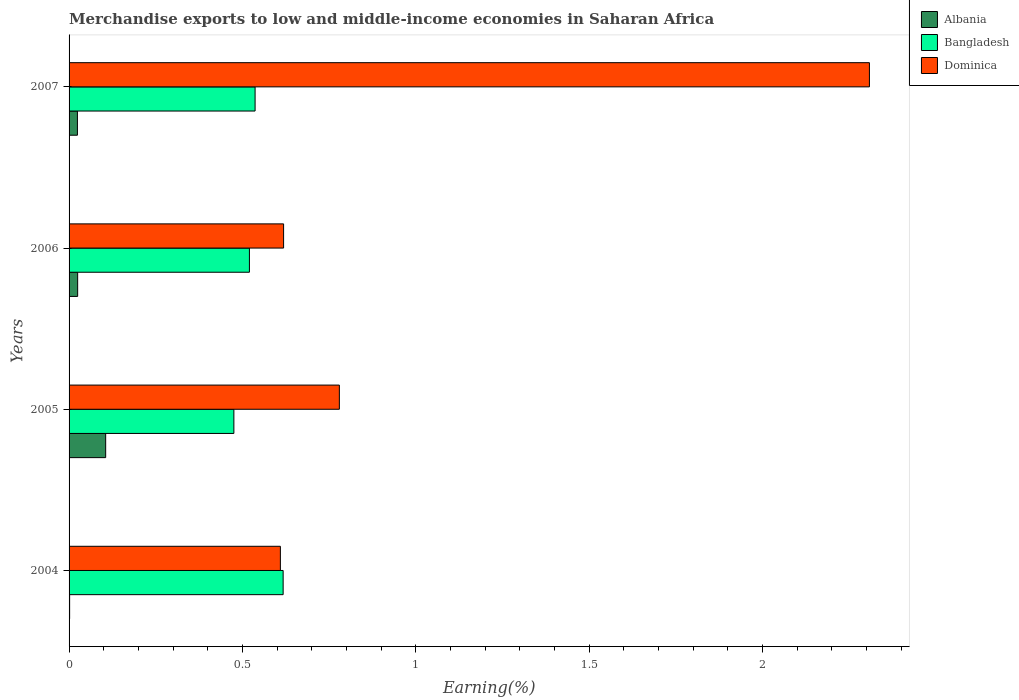Are the number of bars per tick equal to the number of legend labels?
Provide a short and direct response. Yes. Are the number of bars on each tick of the Y-axis equal?
Provide a succinct answer. Yes. How many bars are there on the 2nd tick from the top?
Your response must be concise. 3. What is the label of the 1st group of bars from the top?
Give a very brief answer. 2007. In how many cases, is the number of bars for a given year not equal to the number of legend labels?
Give a very brief answer. 0. What is the percentage of amount earned from merchandise exports in Albania in 2006?
Keep it short and to the point. 0.02. Across all years, what is the maximum percentage of amount earned from merchandise exports in Dominica?
Provide a succinct answer. 2.31. Across all years, what is the minimum percentage of amount earned from merchandise exports in Bangladesh?
Give a very brief answer. 0.48. In which year was the percentage of amount earned from merchandise exports in Dominica maximum?
Your response must be concise. 2007. What is the total percentage of amount earned from merchandise exports in Albania in the graph?
Provide a short and direct response. 0.16. What is the difference between the percentage of amount earned from merchandise exports in Bangladesh in 2005 and that in 2006?
Make the answer very short. -0.04. What is the difference between the percentage of amount earned from merchandise exports in Dominica in 2004 and the percentage of amount earned from merchandise exports in Albania in 2007?
Make the answer very short. 0.59. What is the average percentage of amount earned from merchandise exports in Bangladesh per year?
Keep it short and to the point. 0.54. In the year 2005, what is the difference between the percentage of amount earned from merchandise exports in Dominica and percentage of amount earned from merchandise exports in Albania?
Keep it short and to the point. 0.67. What is the ratio of the percentage of amount earned from merchandise exports in Bangladesh in 2006 to that in 2007?
Ensure brevity in your answer.  0.97. Is the percentage of amount earned from merchandise exports in Bangladesh in 2006 less than that in 2007?
Make the answer very short. Yes. Is the difference between the percentage of amount earned from merchandise exports in Dominica in 2004 and 2006 greater than the difference between the percentage of amount earned from merchandise exports in Albania in 2004 and 2006?
Your response must be concise. Yes. What is the difference between the highest and the second highest percentage of amount earned from merchandise exports in Dominica?
Your answer should be compact. 1.53. What is the difference between the highest and the lowest percentage of amount earned from merchandise exports in Dominica?
Provide a short and direct response. 1.7. Is the sum of the percentage of amount earned from merchandise exports in Albania in 2004 and 2006 greater than the maximum percentage of amount earned from merchandise exports in Dominica across all years?
Provide a succinct answer. No. What does the 3rd bar from the top in 2004 represents?
Provide a succinct answer. Albania. What does the 1st bar from the bottom in 2007 represents?
Offer a terse response. Albania. Is it the case that in every year, the sum of the percentage of amount earned from merchandise exports in Dominica and percentage of amount earned from merchandise exports in Albania is greater than the percentage of amount earned from merchandise exports in Bangladesh?
Your response must be concise. No. How many bars are there?
Provide a succinct answer. 12. Are all the bars in the graph horizontal?
Provide a succinct answer. Yes. How many years are there in the graph?
Keep it short and to the point. 4. Does the graph contain any zero values?
Ensure brevity in your answer.  No. Where does the legend appear in the graph?
Ensure brevity in your answer.  Top right. How many legend labels are there?
Keep it short and to the point. 3. How are the legend labels stacked?
Make the answer very short. Vertical. What is the title of the graph?
Provide a short and direct response. Merchandise exports to low and middle-income economies in Saharan Africa. Does "Gambia, The" appear as one of the legend labels in the graph?
Provide a short and direct response. No. What is the label or title of the X-axis?
Your answer should be compact. Earning(%). What is the label or title of the Y-axis?
Make the answer very short. Years. What is the Earning(%) in Albania in 2004?
Your response must be concise. 0. What is the Earning(%) of Bangladesh in 2004?
Offer a very short reply. 0.62. What is the Earning(%) in Dominica in 2004?
Make the answer very short. 0.61. What is the Earning(%) of Albania in 2005?
Provide a succinct answer. 0.11. What is the Earning(%) of Bangladesh in 2005?
Offer a very short reply. 0.48. What is the Earning(%) in Dominica in 2005?
Offer a very short reply. 0.78. What is the Earning(%) in Albania in 2006?
Give a very brief answer. 0.02. What is the Earning(%) in Bangladesh in 2006?
Keep it short and to the point. 0.52. What is the Earning(%) in Dominica in 2006?
Offer a terse response. 0.62. What is the Earning(%) in Albania in 2007?
Give a very brief answer. 0.02. What is the Earning(%) of Bangladesh in 2007?
Provide a succinct answer. 0.54. What is the Earning(%) of Dominica in 2007?
Offer a very short reply. 2.31. Across all years, what is the maximum Earning(%) in Albania?
Give a very brief answer. 0.11. Across all years, what is the maximum Earning(%) in Bangladesh?
Ensure brevity in your answer.  0.62. Across all years, what is the maximum Earning(%) in Dominica?
Your response must be concise. 2.31. Across all years, what is the minimum Earning(%) in Albania?
Offer a very short reply. 0. Across all years, what is the minimum Earning(%) in Bangladesh?
Make the answer very short. 0.48. Across all years, what is the minimum Earning(%) in Dominica?
Your response must be concise. 0.61. What is the total Earning(%) in Albania in the graph?
Your response must be concise. 0.16. What is the total Earning(%) in Bangladesh in the graph?
Ensure brevity in your answer.  2.15. What is the total Earning(%) in Dominica in the graph?
Your response must be concise. 4.32. What is the difference between the Earning(%) in Albania in 2004 and that in 2005?
Ensure brevity in your answer.  -0.1. What is the difference between the Earning(%) of Bangladesh in 2004 and that in 2005?
Offer a very short reply. 0.14. What is the difference between the Earning(%) of Dominica in 2004 and that in 2005?
Your answer should be compact. -0.17. What is the difference between the Earning(%) of Albania in 2004 and that in 2006?
Provide a succinct answer. -0.02. What is the difference between the Earning(%) of Bangladesh in 2004 and that in 2006?
Your response must be concise. 0.1. What is the difference between the Earning(%) in Dominica in 2004 and that in 2006?
Keep it short and to the point. -0.01. What is the difference between the Earning(%) of Albania in 2004 and that in 2007?
Your answer should be very brief. -0.02. What is the difference between the Earning(%) in Bangladesh in 2004 and that in 2007?
Keep it short and to the point. 0.08. What is the difference between the Earning(%) of Dominica in 2004 and that in 2007?
Provide a succinct answer. -1.7. What is the difference between the Earning(%) of Albania in 2005 and that in 2006?
Keep it short and to the point. 0.08. What is the difference between the Earning(%) of Bangladesh in 2005 and that in 2006?
Your answer should be compact. -0.04. What is the difference between the Earning(%) in Dominica in 2005 and that in 2006?
Offer a very short reply. 0.16. What is the difference between the Earning(%) of Albania in 2005 and that in 2007?
Your response must be concise. 0.08. What is the difference between the Earning(%) in Bangladesh in 2005 and that in 2007?
Provide a succinct answer. -0.06. What is the difference between the Earning(%) of Dominica in 2005 and that in 2007?
Keep it short and to the point. -1.53. What is the difference between the Earning(%) of Albania in 2006 and that in 2007?
Make the answer very short. 0. What is the difference between the Earning(%) of Bangladesh in 2006 and that in 2007?
Your answer should be very brief. -0.02. What is the difference between the Earning(%) in Dominica in 2006 and that in 2007?
Make the answer very short. -1.69. What is the difference between the Earning(%) in Albania in 2004 and the Earning(%) in Bangladesh in 2005?
Offer a terse response. -0.47. What is the difference between the Earning(%) in Albania in 2004 and the Earning(%) in Dominica in 2005?
Offer a very short reply. -0.78. What is the difference between the Earning(%) in Bangladesh in 2004 and the Earning(%) in Dominica in 2005?
Ensure brevity in your answer.  -0.16. What is the difference between the Earning(%) in Albania in 2004 and the Earning(%) in Bangladesh in 2006?
Provide a succinct answer. -0.52. What is the difference between the Earning(%) in Albania in 2004 and the Earning(%) in Dominica in 2006?
Offer a terse response. -0.62. What is the difference between the Earning(%) of Bangladesh in 2004 and the Earning(%) of Dominica in 2006?
Your response must be concise. -0. What is the difference between the Earning(%) of Albania in 2004 and the Earning(%) of Bangladesh in 2007?
Offer a terse response. -0.54. What is the difference between the Earning(%) of Albania in 2004 and the Earning(%) of Dominica in 2007?
Offer a very short reply. -2.31. What is the difference between the Earning(%) in Bangladesh in 2004 and the Earning(%) in Dominica in 2007?
Your response must be concise. -1.69. What is the difference between the Earning(%) in Albania in 2005 and the Earning(%) in Bangladesh in 2006?
Provide a succinct answer. -0.41. What is the difference between the Earning(%) in Albania in 2005 and the Earning(%) in Dominica in 2006?
Your answer should be compact. -0.51. What is the difference between the Earning(%) in Bangladesh in 2005 and the Earning(%) in Dominica in 2006?
Your answer should be compact. -0.14. What is the difference between the Earning(%) of Albania in 2005 and the Earning(%) of Bangladesh in 2007?
Your response must be concise. -0.43. What is the difference between the Earning(%) in Albania in 2005 and the Earning(%) in Dominica in 2007?
Ensure brevity in your answer.  -2.2. What is the difference between the Earning(%) of Bangladesh in 2005 and the Earning(%) of Dominica in 2007?
Provide a short and direct response. -1.83. What is the difference between the Earning(%) of Albania in 2006 and the Earning(%) of Bangladesh in 2007?
Your response must be concise. -0.51. What is the difference between the Earning(%) in Albania in 2006 and the Earning(%) in Dominica in 2007?
Give a very brief answer. -2.28. What is the difference between the Earning(%) of Bangladesh in 2006 and the Earning(%) of Dominica in 2007?
Offer a very short reply. -1.79. What is the average Earning(%) in Albania per year?
Offer a terse response. 0.04. What is the average Earning(%) of Bangladesh per year?
Make the answer very short. 0.54. What is the average Earning(%) in Dominica per year?
Make the answer very short. 1.08. In the year 2004, what is the difference between the Earning(%) in Albania and Earning(%) in Bangladesh?
Your answer should be compact. -0.62. In the year 2004, what is the difference between the Earning(%) in Albania and Earning(%) in Dominica?
Make the answer very short. -0.61. In the year 2004, what is the difference between the Earning(%) in Bangladesh and Earning(%) in Dominica?
Provide a succinct answer. 0.01. In the year 2005, what is the difference between the Earning(%) of Albania and Earning(%) of Bangladesh?
Your answer should be very brief. -0.37. In the year 2005, what is the difference between the Earning(%) in Albania and Earning(%) in Dominica?
Offer a very short reply. -0.67. In the year 2005, what is the difference between the Earning(%) of Bangladesh and Earning(%) of Dominica?
Keep it short and to the point. -0.3. In the year 2006, what is the difference between the Earning(%) in Albania and Earning(%) in Bangladesh?
Your response must be concise. -0.5. In the year 2006, what is the difference between the Earning(%) of Albania and Earning(%) of Dominica?
Your answer should be very brief. -0.59. In the year 2006, what is the difference between the Earning(%) of Bangladesh and Earning(%) of Dominica?
Provide a succinct answer. -0.1. In the year 2007, what is the difference between the Earning(%) in Albania and Earning(%) in Bangladesh?
Your answer should be compact. -0.51. In the year 2007, what is the difference between the Earning(%) of Albania and Earning(%) of Dominica?
Your answer should be very brief. -2.28. In the year 2007, what is the difference between the Earning(%) in Bangladesh and Earning(%) in Dominica?
Offer a terse response. -1.77. What is the ratio of the Earning(%) of Albania in 2004 to that in 2005?
Your answer should be very brief. 0.02. What is the ratio of the Earning(%) of Bangladesh in 2004 to that in 2005?
Your answer should be very brief. 1.3. What is the ratio of the Earning(%) in Dominica in 2004 to that in 2005?
Your response must be concise. 0.78. What is the ratio of the Earning(%) of Albania in 2004 to that in 2006?
Offer a very short reply. 0.07. What is the ratio of the Earning(%) of Bangladesh in 2004 to that in 2006?
Offer a terse response. 1.19. What is the ratio of the Earning(%) of Dominica in 2004 to that in 2006?
Your answer should be very brief. 0.98. What is the ratio of the Earning(%) of Albania in 2004 to that in 2007?
Provide a short and direct response. 0.07. What is the ratio of the Earning(%) in Bangladesh in 2004 to that in 2007?
Offer a very short reply. 1.15. What is the ratio of the Earning(%) of Dominica in 2004 to that in 2007?
Offer a very short reply. 0.26. What is the ratio of the Earning(%) of Albania in 2005 to that in 2006?
Your answer should be compact. 4.26. What is the ratio of the Earning(%) of Bangladesh in 2005 to that in 2006?
Offer a very short reply. 0.91. What is the ratio of the Earning(%) in Dominica in 2005 to that in 2006?
Ensure brevity in your answer.  1.26. What is the ratio of the Earning(%) in Albania in 2005 to that in 2007?
Your answer should be very brief. 4.38. What is the ratio of the Earning(%) in Bangladesh in 2005 to that in 2007?
Your response must be concise. 0.89. What is the ratio of the Earning(%) of Dominica in 2005 to that in 2007?
Your answer should be compact. 0.34. What is the ratio of the Earning(%) in Albania in 2006 to that in 2007?
Ensure brevity in your answer.  1.03. What is the ratio of the Earning(%) in Bangladesh in 2006 to that in 2007?
Give a very brief answer. 0.97. What is the ratio of the Earning(%) of Dominica in 2006 to that in 2007?
Keep it short and to the point. 0.27. What is the difference between the highest and the second highest Earning(%) in Albania?
Your answer should be compact. 0.08. What is the difference between the highest and the second highest Earning(%) of Bangladesh?
Your answer should be compact. 0.08. What is the difference between the highest and the second highest Earning(%) of Dominica?
Your answer should be very brief. 1.53. What is the difference between the highest and the lowest Earning(%) of Albania?
Ensure brevity in your answer.  0.1. What is the difference between the highest and the lowest Earning(%) in Bangladesh?
Your answer should be very brief. 0.14. What is the difference between the highest and the lowest Earning(%) of Dominica?
Give a very brief answer. 1.7. 